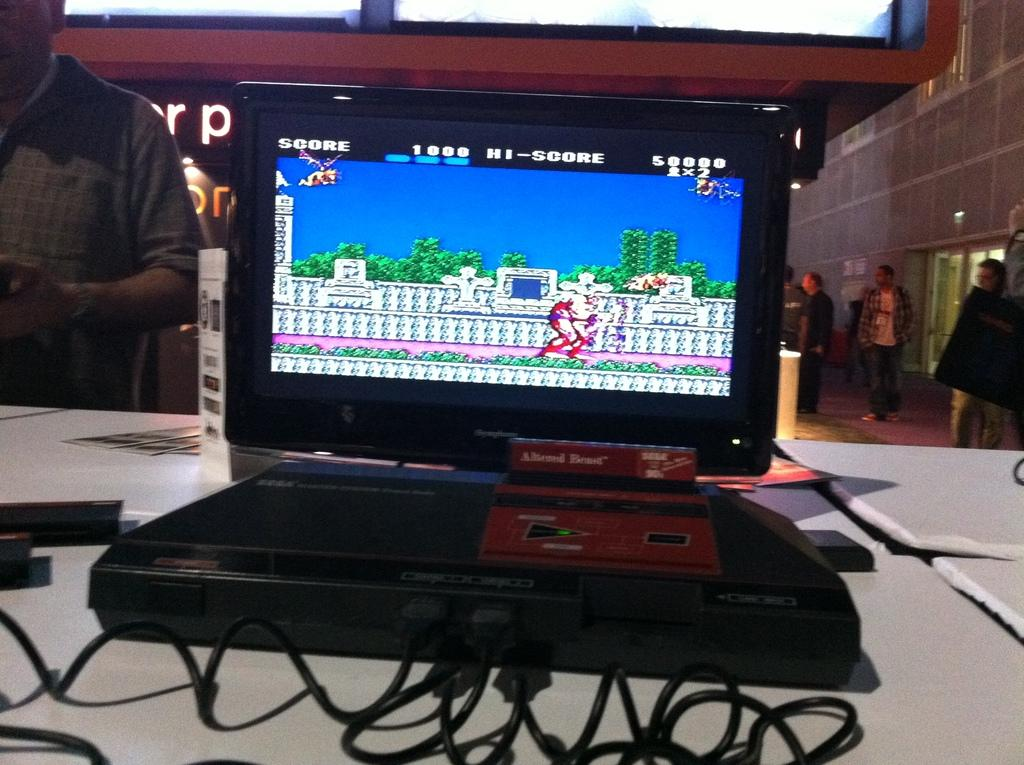<image>
Provide a brief description of the given image. A video game screen shows a score of 1000 with a Hi-score of 5000. 